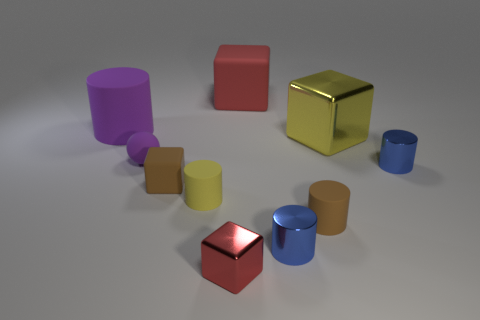There is a object that is the same color as the big matte cylinder; what is its material?
Your answer should be compact. Rubber. What number of brown matte objects are the same shape as the small yellow thing?
Ensure brevity in your answer.  1. Does the large purple thing have the same material as the big block that is behind the big purple object?
Offer a terse response. Yes. There is another cube that is the same size as the red rubber block; what material is it?
Keep it short and to the point. Metal. Is there a gray metallic thing that has the same size as the brown cylinder?
Provide a succinct answer. No. There is a yellow metal object that is the same size as the red rubber object; what shape is it?
Provide a short and direct response. Cube. How many other things are the same color as the rubber sphere?
Offer a very short reply. 1. There is a thing that is behind the yellow block and to the left of the yellow cylinder; what shape is it?
Offer a terse response. Cylinder. There is a purple object to the right of the purple rubber object that is behind the yellow shiny thing; are there any small yellow cylinders on the left side of it?
Offer a very short reply. No. What number of other things are the same material as the purple sphere?
Your response must be concise. 5. 